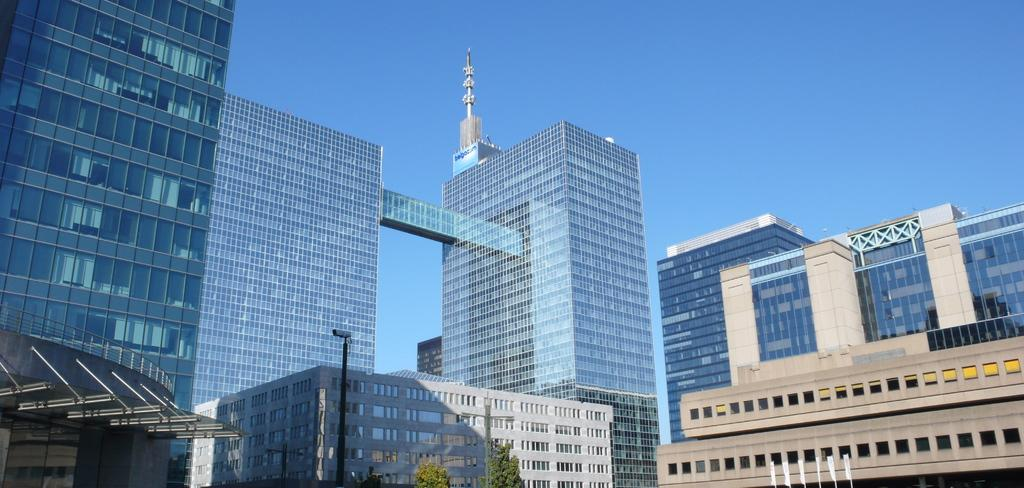What is located at the bottom of the image? There is a pole, a camera, flags, trees, and buildings at the bottom of the image. What can be seen in the background of the image? There are buildings and a tower in the background of the image, along with the sky. What type of produce is being harvested in the image? There is no produce visible in the image. What time of day is it in the image, considering the lighting and shadows? The time of day cannot be determined from the image, as there is no specific information about lighting or shadows provided. 